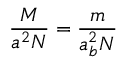Convert formula to latex. <formula><loc_0><loc_0><loc_500><loc_500>{ \frac { M } { a ^ { 2 } N } } = { \frac { m } { a _ { b } ^ { 2 } N } }</formula> 